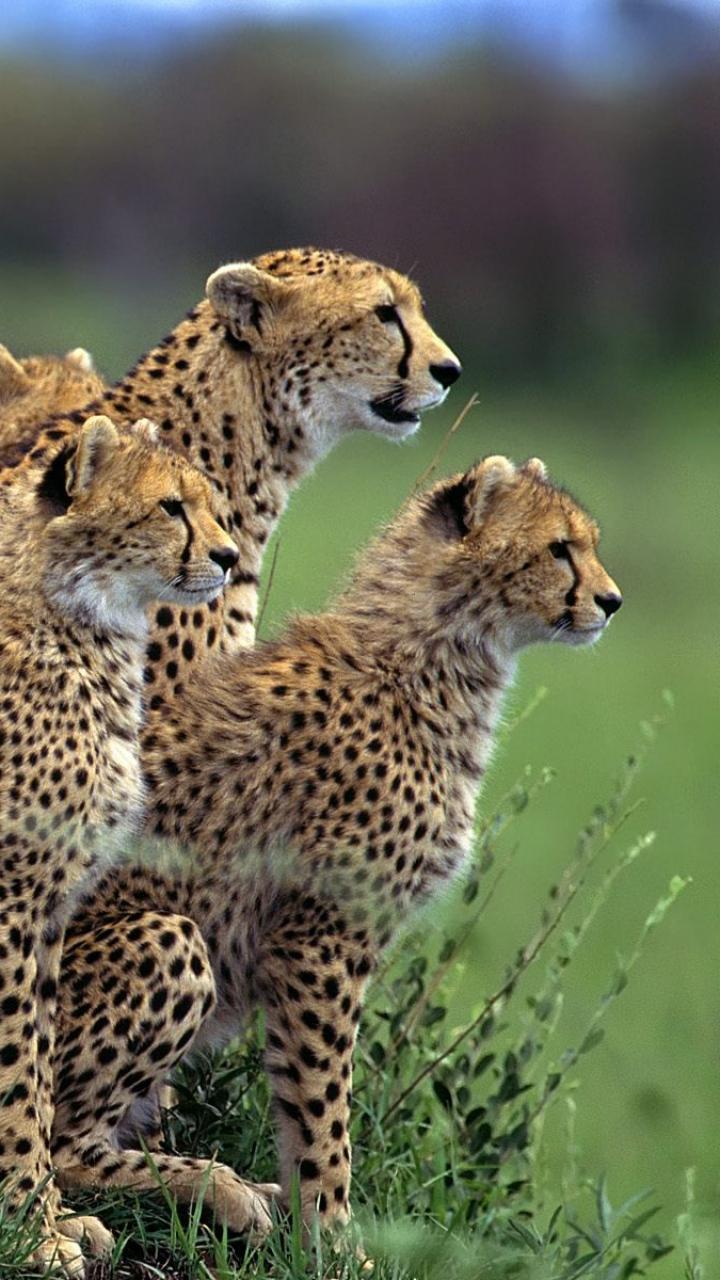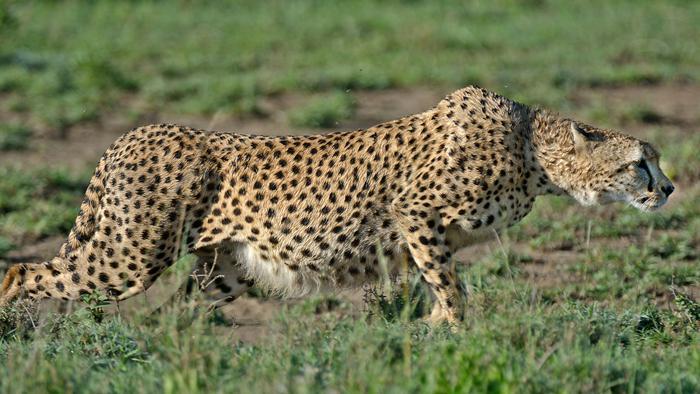The first image is the image on the left, the second image is the image on the right. For the images displayed, is the sentence "The leopards in one of the images are moving quickly across the field." factually correct? Answer yes or no. No. The first image is the image on the left, the second image is the image on the right. For the images displayed, is the sentence "Multiple spotted wild cats are in action poses in one of the images." factually correct? Answer yes or no. No. 